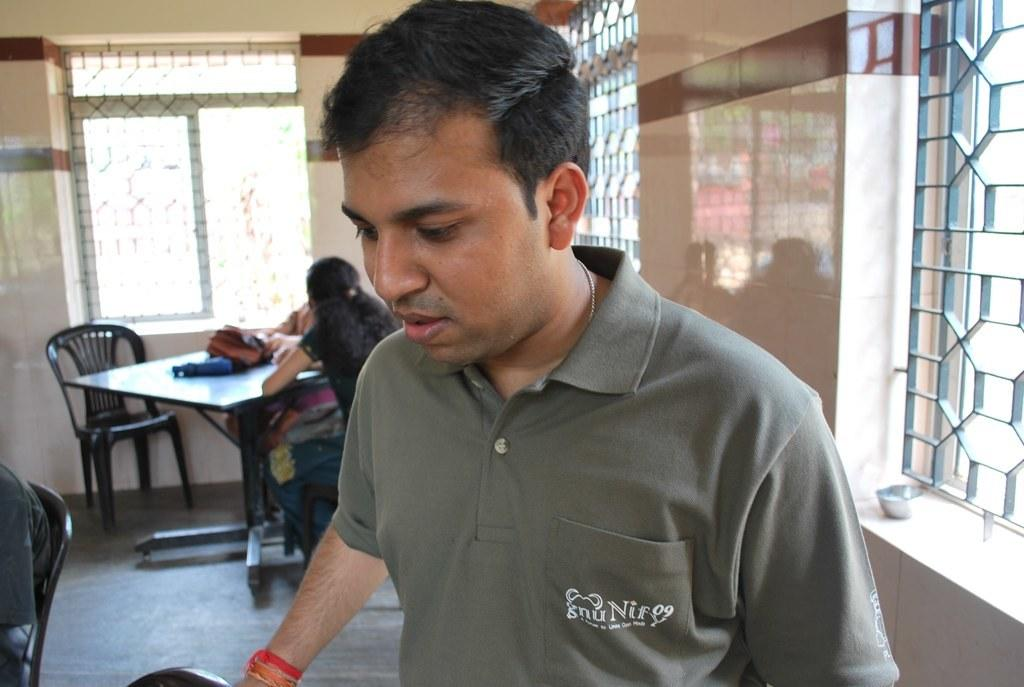What is the man in the image wearing? The man is wearing a grey t-shirt. Where is the man located in the image? The man is standing in front of a window. What other objects or furniture can be seen in the image? There is a table in the image. How many people are sitting around the table? There are two persons sitting around the table. What type of establishment might the setting suggest? The setting appears to be a small hotel. What type of committee can be seen meeting at the seashore in the image? There is no committee or seashore present in the image; it features a man in a grey t-shirt standing in front of a window, a table, and two persons sitting around it. 